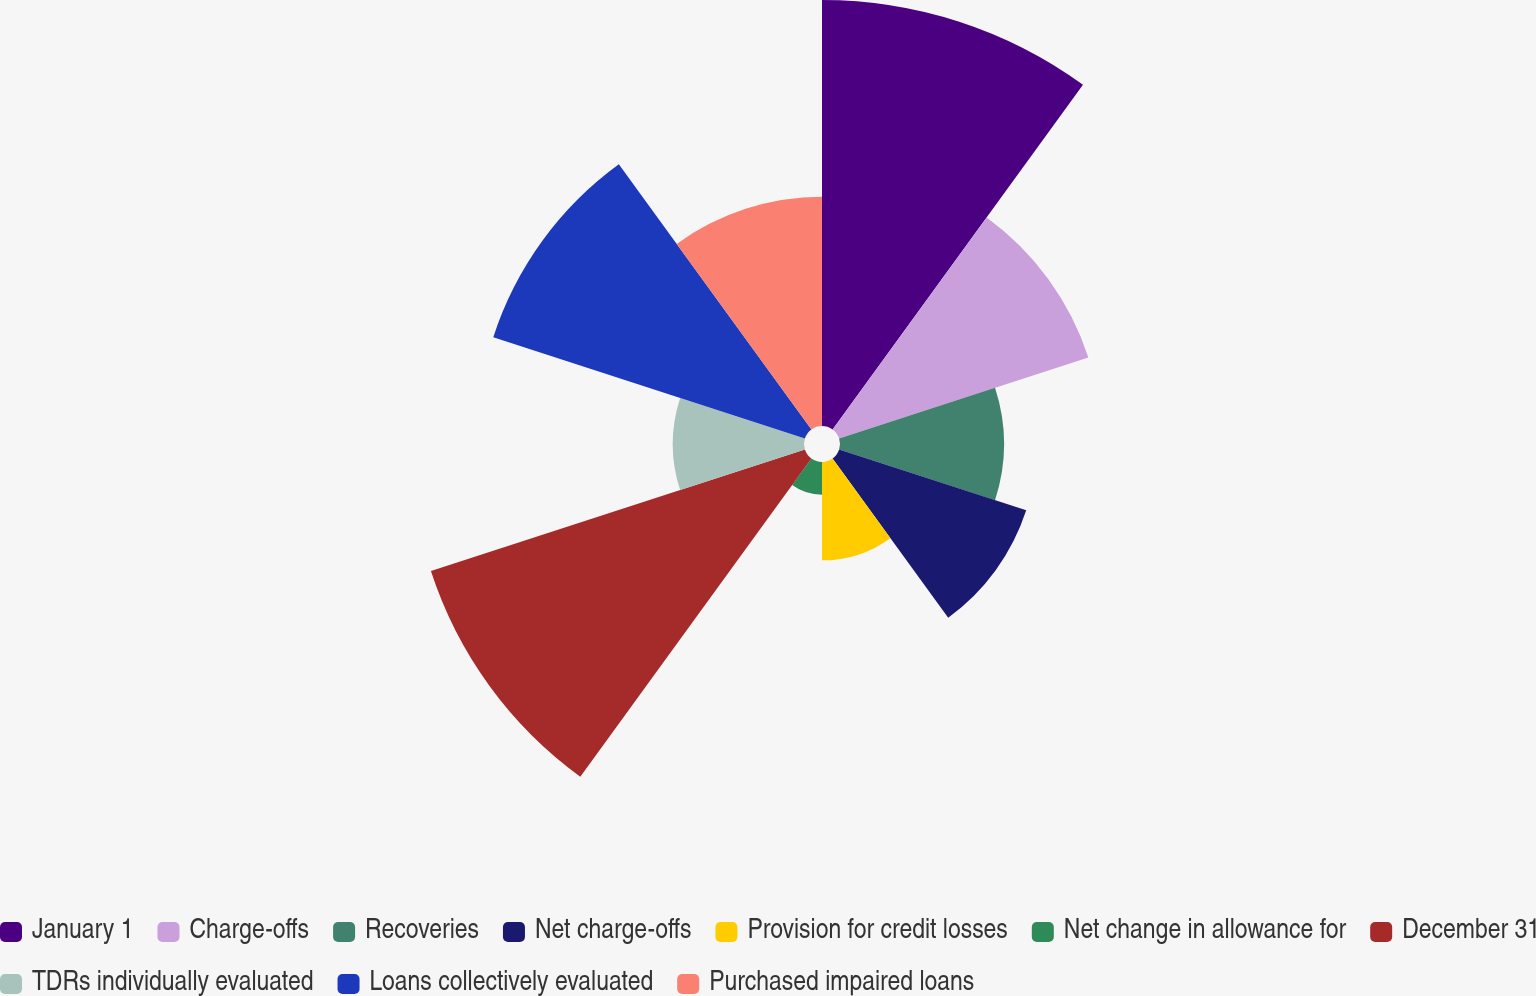Convert chart. <chart><loc_0><loc_0><loc_500><loc_500><pie_chart><fcel>January 1<fcel>Charge-offs<fcel>Recoveries<fcel>Net charge-offs<fcel>Provision for credit losses<fcel>Net change in allowance for<fcel>December 31<fcel>TDRs individually evaluated<fcel>Loans collectively evaluated<fcel>Purchased impaired loans<nl><fcel>18.84%<fcel>11.59%<fcel>7.25%<fcel>8.7%<fcel>4.35%<fcel>1.45%<fcel>17.39%<fcel>5.8%<fcel>14.49%<fcel>10.14%<nl></chart> 